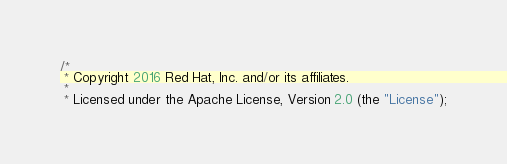<code> <loc_0><loc_0><loc_500><loc_500><_Java_>/*
 * Copyright 2016 Red Hat, Inc. and/or its affiliates.
 *
 * Licensed under the Apache License, Version 2.0 (the "License");</code> 